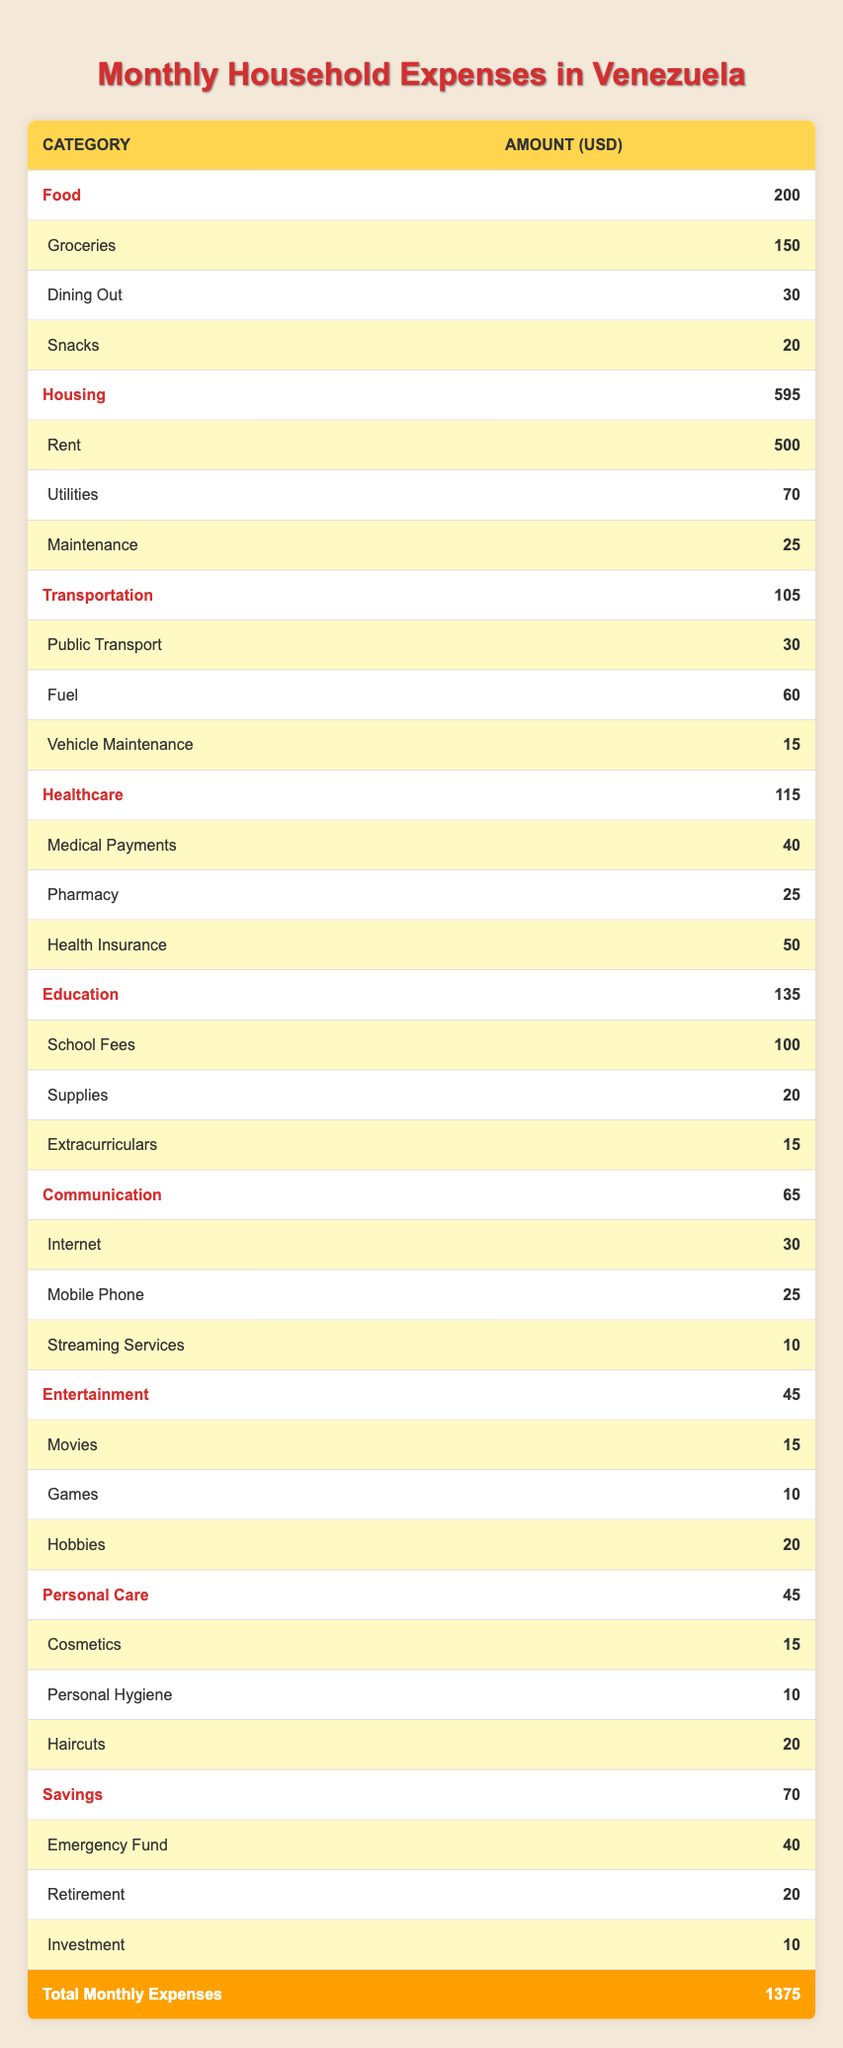What is the total amount spent on Food per month? The table shows the Food category with three subcategories: Groceries (150), Dining Out (30), and Snacks (20). Adding these amounts gives us a total of 150 + 30 + 20 = 200.
Answer: 200 Which category has the highest expenditure? By reviewing the total amounts for each category, Housing has the highest total expense of 595, compared to other categories.
Answer: Housing How much more is spent on Rent than on Utilities? Rent costs 500 and Utilities cost 70. The difference is calculated as 500 - 70 = 430, indicating that Rent is 430 higher than Utilities.
Answer: 430 What is the combined amount for Healthcare and Education? The total for Healthcare is 115 and for Education is 135. Adding these gives us 115 + 135 = 250.
Answer: 250 Is the amount spent on Personal Care higher than that on Entertainment? Personal Care costs 45 and Entertainment costs 45 as well. Both amounts are equal, so the answer is no; Personal Care is not higher than Entertainment.
Answer: No What is the average monthly spending on the subcategories of Communication? The subcategories under Communication are Internet (30), Mobile Phone (25), and Streaming Services (10). To find the average, we first total them (30 + 25 + 10 = 65) and then divide by the number of subcategories, which is 3. So, 65/3 = approximately 21.67.
Answer: 21.67 If I save the entire amount in Savings, what percentage of the total monthly expenses would it represent? Savings total 70 and the grand total of monthly expenses is 1375. The percentage is calculated as (70/1375) * 100 = 5.09%.
Answer: 5.09% What is the total spent on all categories? The table indicates the total monthly expenses sum up to 1375, which includes all individual category amounts.
Answer: 1375 How does the total expenditure on Transportation compare to that of Healthcare? Transportation totals at 105, while Healthcare totals at 115. To compare, we see that Healthcare (115) is 10 more than Transportation (105).
Answer: 10 more What is the total spent on Education subcategories? The total for Education is calculated by adding School Fees (100), Supplies (20), and Extracurriculars (15), which totals 100 + 20 + 15 = 135.
Answer: 135 